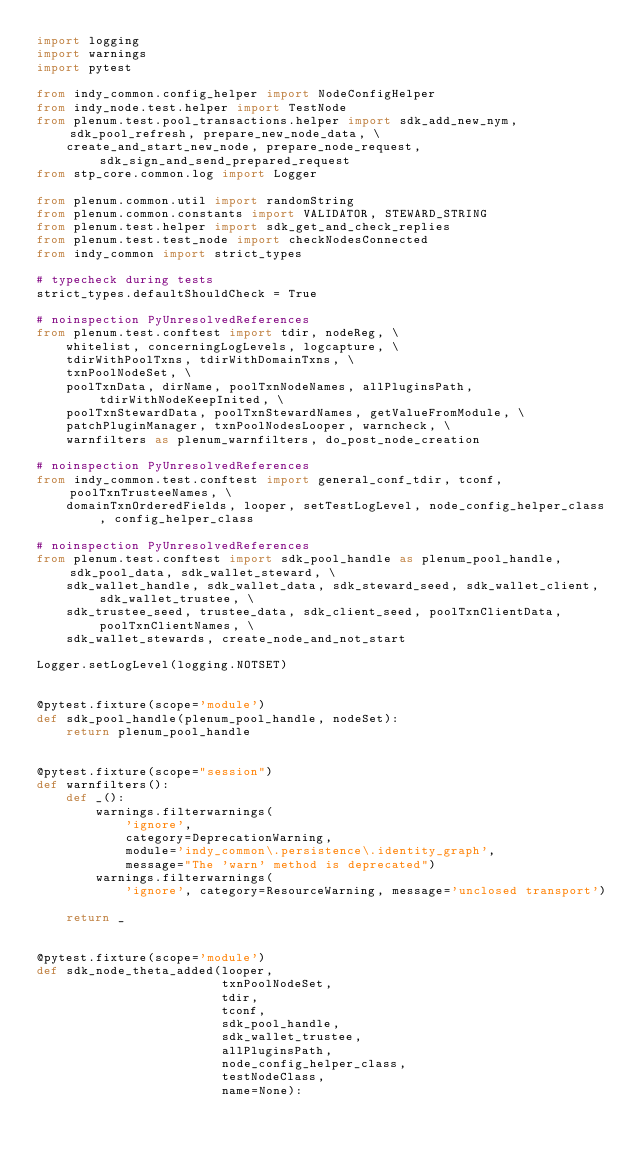Convert code to text. <code><loc_0><loc_0><loc_500><loc_500><_Python_>import logging
import warnings
import pytest

from indy_common.config_helper import NodeConfigHelper
from indy_node.test.helper import TestNode
from plenum.test.pool_transactions.helper import sdk_add_new_nym, sdk_pool_refresh, prepare_new_node_data, \
    create_and_start_new_node, prepare_node_request, sdk_sign_and_send_prepared_request
from stp_core.common.log import Logger

from plenum.common.util import randomString
from plenum.common.constants import VALIDATOR, STEWARD_STRING
from plenum.test.helper import sdk_get_and_check_replies
from plenum.test.test_node import checkNodesConnected
from indy_common import strict_types

# typecheck during tests
strict_types.defaultShouldCheck = True

# noinspection PyUnresolvedReferences
from plenum.test.conftest import tdir, nodeReg, \
    whitelist, concerningLogLevels, logcapture, \
    tdirWithPoolTxns, tdirWithDomainTxns, \
    txnPoolNodeSet, \
    poolTxnData, dirName, poolTxnNodeNames, allPluginsPath, tdirWithNodeKeepInited, \
    poolTxnStewardData, poolTxnStewardNames, getValueFromModule, \
    patchPluginManager, txnPoolNodesLooper, warncheck, \
    warnfilters as plenum_warnfilters, do_post_node_creation

# noinspection PyUnresolvedReferences
from indy_common.test.conftest import general_conf_tdir, tconf, poolTxnTrusteeNames, \
    domainTxnOrderedFields, looper, setTestLogLevel, node_config_helper_class, config_helper_class

# noinspection PyUnresolvedReferences
from plenum.test.conftest import sdk_pool_handle as plenum_pool_handle, sdk_pool_data, sdk_wallet_steward, \
    sdk_wallet_handle, sdk_wallet_data, sdk_steward_seed, sdk_wallet_client, sdk_wallet_trustee, \
    sdk_trustee_seed, trustee_data, sdk_client_seed, poolTxnClientData, poolTxnClientNames, \
    sdk_wallet_stewards, create_node_and_not_start

Logger.setLogLevel(logging.NOTSET)


@pytest.fixture(scope='module')
def sdk_pool_handle(plenum_pool_handle, nodeSet):
    return plenum_pool_handle


@pytest.fixture(scope="session")
def warnfilters():
    def _():
        warnings.filterwarnings(
            'ignore',
            category=DeprecationWarning,
            module='indy_common\.persistence\.identity_graph',
            message="The 'warn' method is deprecated")
        warnings.filterwarnings(
            'ignore', category=ResourceWarning, message='unclosed transport')

    return _


@pytest.fixture(scope='module')
def sdk_node_theta_added(looper,
                         txnPoolNodeSet,
                         tdir,
                         tconf,
                         sdk_pool_handle,
                         sdk_wallet_trustee,
                         allPluginsPath,
                         node_config_helper_class,
                         testNodeClass,
                         name=None):</code> 